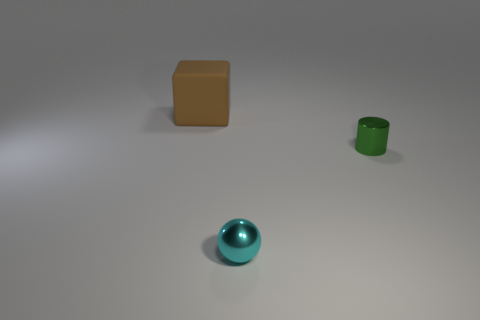There is a big brown thing; does it have the same shape as the small object right of the tiny metal ball?
Ensure brevity in your answer.  No. How many rubber objects are the same size as the shiny sphere?
Your response must be concise. 0. Does the metallic object on the left side of the green metallic cylinder have the same shape as the thing behind the small cylinder?
Provide a short and direct response. No. There is a thing that is behind the metallic thing behind the small cyan object; what is its color?
Your answer should be very brief. Brown. Is there anything else that has the same material as the ball?
Offer a very short reply. Yes. What material is the thing that is behind the small green cylinder?
Offer a terse response. Rubber. Is the number of brown things that are on the left side of the tiny cyan metallic object less than the number of big cyan rubber cylinders?
Make the answer very short. No. What is the shape of the small thing that is left of the small metal thing that is behind the small cyan metal sphere?
Keep it short and to the point. Sphere. What color is the matte block?
Your answer should be compact. Brown. What number of other objects are there of the same size as the sphere?
Provide a succinct answer. 1. 